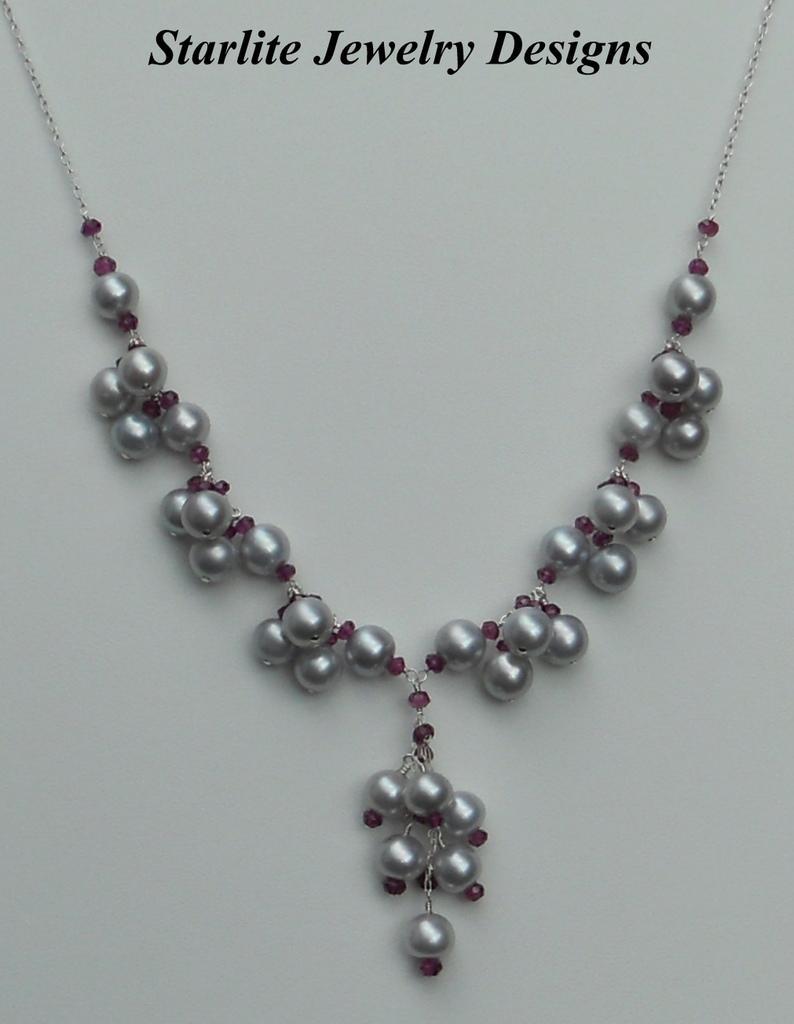In one or two sentences, can you explain what this image depicts? In this picture we can see an ornament, at the top of the image we can find some text. 